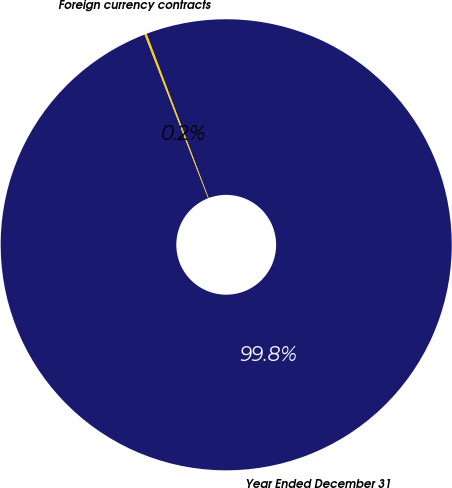Convert chart to OTSL. <chart><loc_0><loc_0><loc_500><loc_500><pie_chart><fcel>Year Ended December 31<fcel>Foreign currency contracts<nl><fcel>99.85%<fcel>0.15%<nl></chart> 